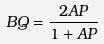<formula> <loc_0><loc_0><loc_500><loc_500>B Q = \frac { 2 A P } { 1 + A P }</formula> 